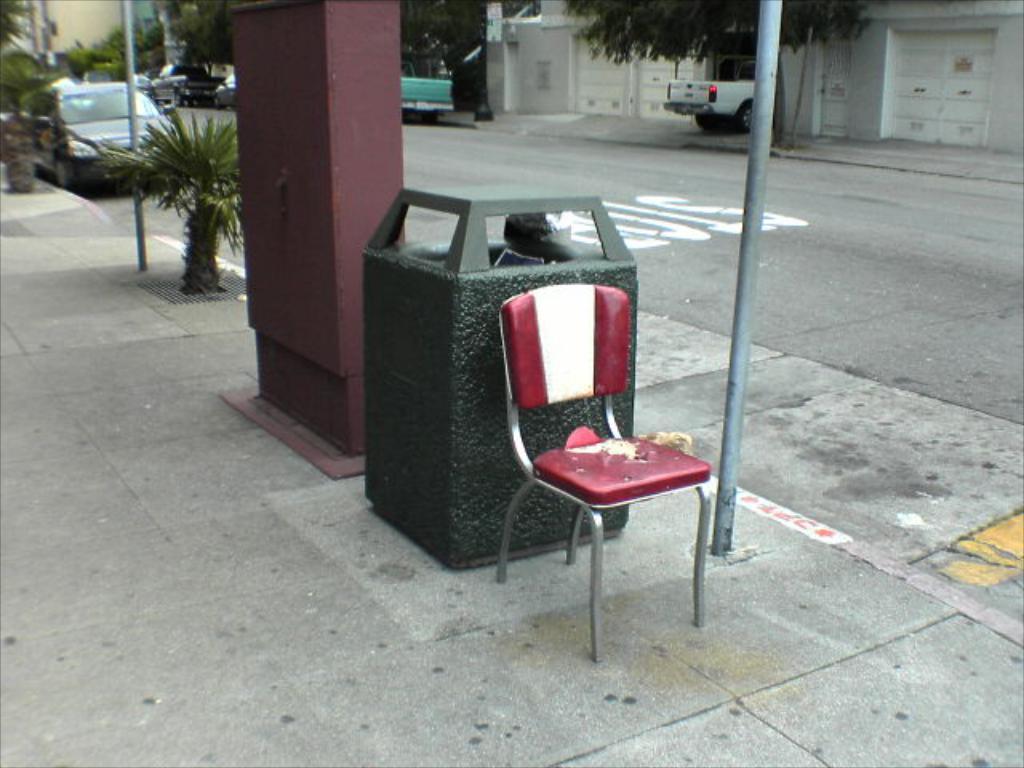Can you describe this image briefly? In this image there is ground towards the bottom of the image, there is a chair, there is a dustbin, there are plants, there are trees towards the top of the image, there is a building towards the top of the image, there are doors, there is a wall, there are poles towards the top of the image, there are objects on the ground, there is road towards the right of the image, there is text on the road, there are vehicles on the road. 